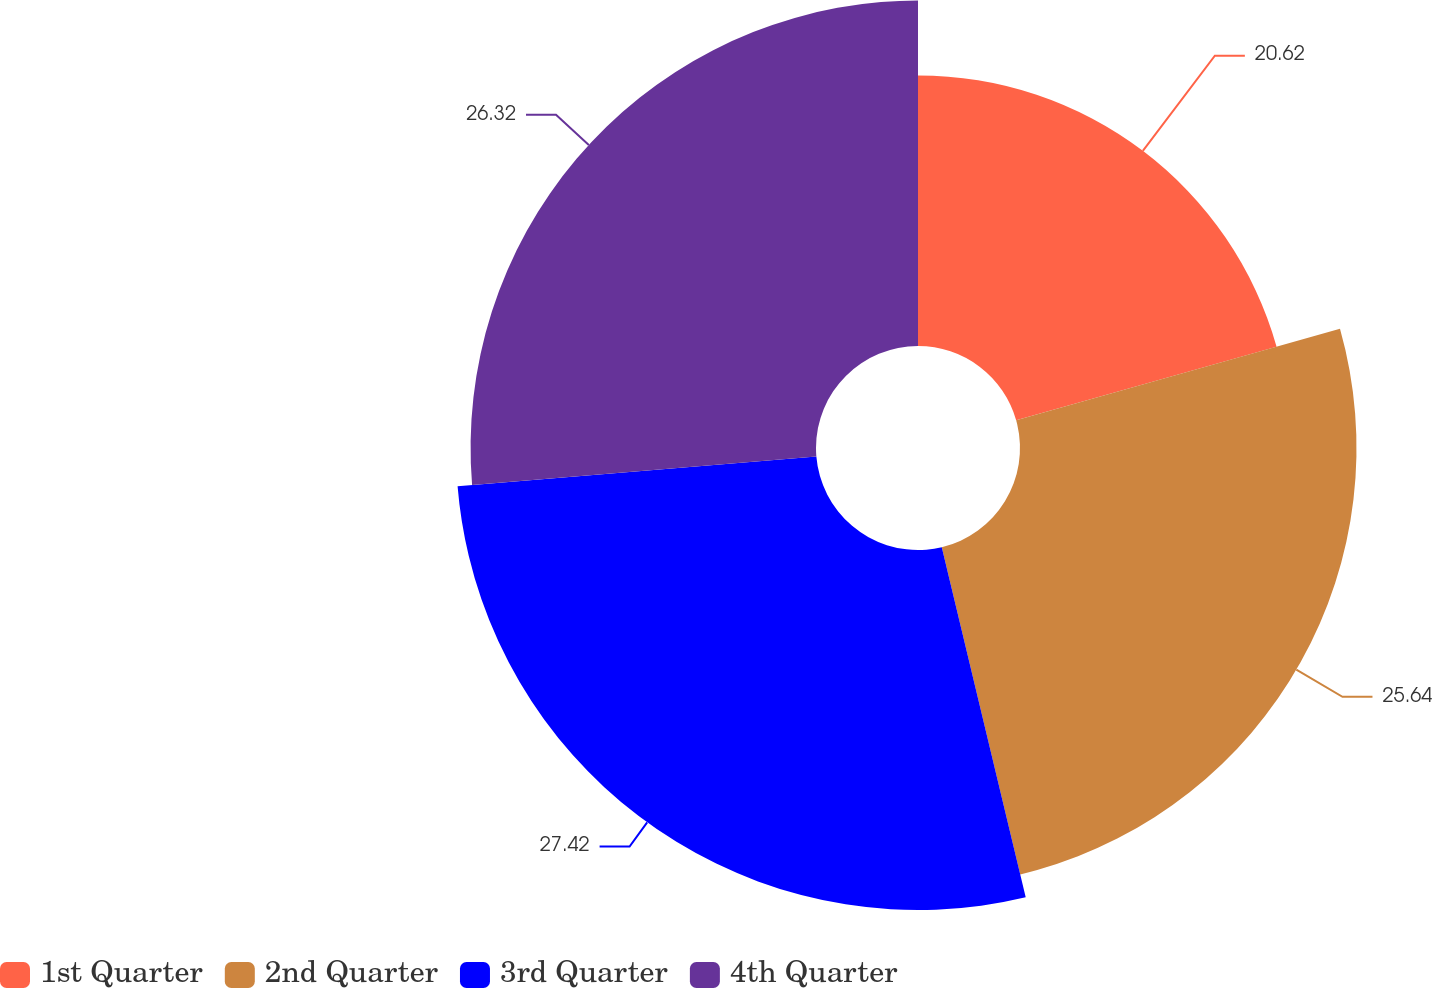<chart> <loc_0><loc_0><loc_500><loc_500><pie_chart><fcel>1st Quarter<fcel>2nd Quarter<fcel>3rd Quarter<fcel>4th Quarter<nl><fcel>20.62%<fcel>25.64%<fcel>27.43%<fcel>26.32%<nl></chart> 